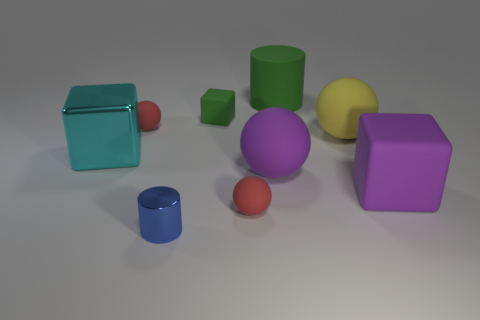Add 1 matte objects. How many objects exist? 10 Subtract all blocks. How many objects are left? 6 Add 1 metallic cubes. How many metallic cubes exist? 2 Subtract 0 blue blocks. How many objects are left? 9 Subtract all big cyan spheres. Subtract all blue metal things. How many objects are left? 8 Add 3 large balls. How many large balls are left? 5 